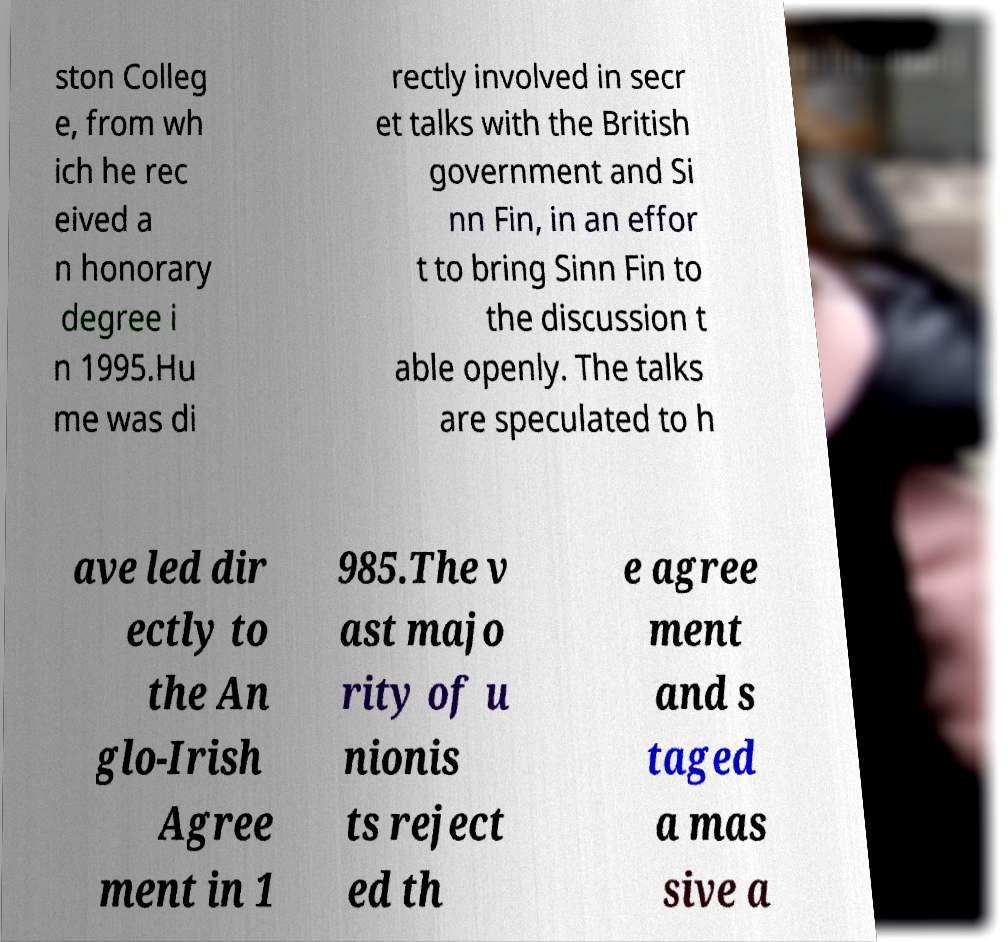Please identify and transcribe the text found in this image. ston Colleg e, from wh ich he rec eived a n honorary degree i n 1995.Hu me was di rectly involved in secr et talks with the British government and Si nn Fin, in an effor t to bring Sinn Fin to the discussion t able openly. The talks are speculated to h ave led dir ectly to the An glo-Irish Agree ment in 1 985.The v ast majo rity of u nionis ts reject ed th e agree ment and s taged a mas sive a 